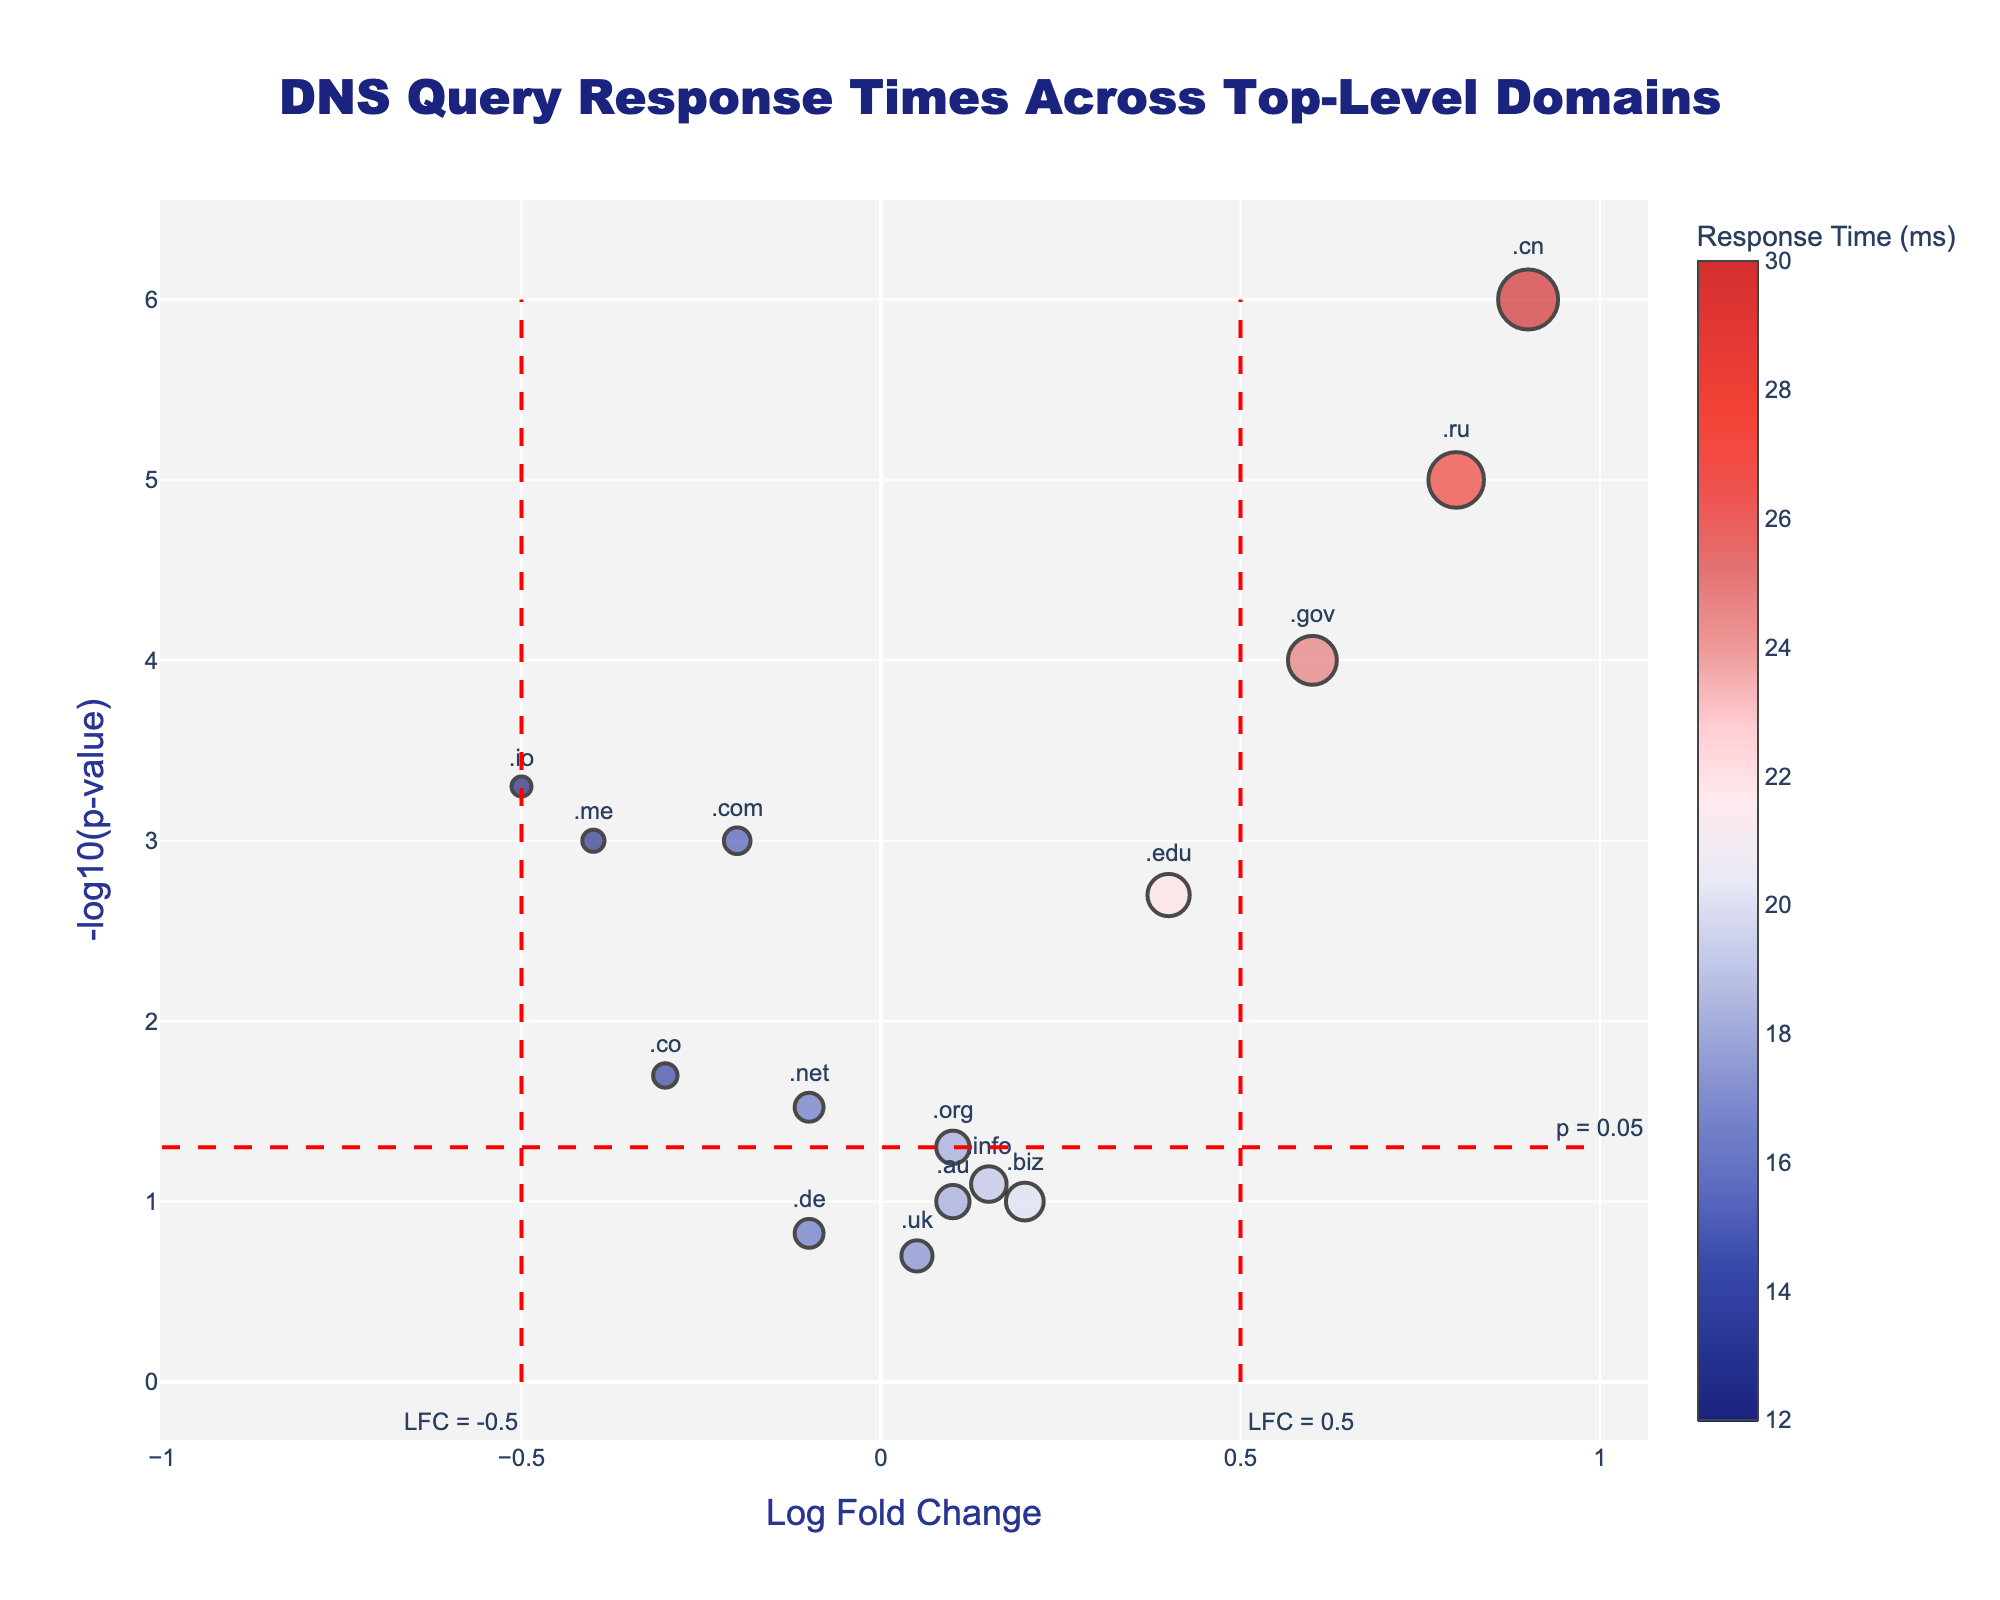What is the title of the figure? The title is located at the top center of the plot and is displayed in a large font.
Answer: DNS Query Response Times Across Top-Level Domains How many top-level domains (TLDs) are represented in the figure? To find the number of TLDs, count the number of markers or the number of labels in the plot.
Answer: 15 Which TLD has the highest response time, and what is its value? Identify the marker with the largest color gradient and hover over it or read the hovertext.
Answer: .cn, 30 ms Which TLD has the smallest p-value, and what is its value? Find the marker located highest on the y-axis, representing the smallest p-value as -log10(p-value) increases upward.
Answer: .cn, 0.000001 Which TLD shows the most significant positive fold change (Log Fold Change) and what is the value? Locate the marker furthest to the right on the x-axis as it represents the largest positive Log Fold Change.
Answer: .cn, 0.9 Compare the p-values of .edu and .gov. Which one has a smaller p-value, and by how much? Identify the position on the y-axis for both .edu and .gov and observe the values: both p-values are converted to -log10(p-value). Calculate the difference.
Answer: .gov's p-value is smaller by 0.002 - 0.0001 = 0.0019 Is the TLD .uk considered a significant performance outlier, and why? Determine if .uk lies outside the significance threshold lines on the y-axis (p-value) and the x-axis (Log Fold Change).
Answer: No, it is not outside the significance threshold lines List the TLDs that have a negative Log Fold Change and a p-value below the 0.05 threshold. Find markers where the x-coordinate (Log Fold Change) is negative and the y-coordinate (-log10(p-value)) indicates a p-value below 0.05.
Answer: .com, .io, .me, .co What is the average response time of TLDs having a Log Fold Change greater than 0? Identify TLDs to the right of the y-axis (positive Log Fold Change), sum their response times, and divide by their count.
Answer: (18+22+25+20+19+18+28+30) / 8 = 180 / 8 = 22.5 ms How does the response time of .ru compare to the response time of .net? Identify the response times of .ru and .net from the hovertext and compare them directly.
Answer: .ru has a higher response time than .net (28 ms vs 16 ms) 